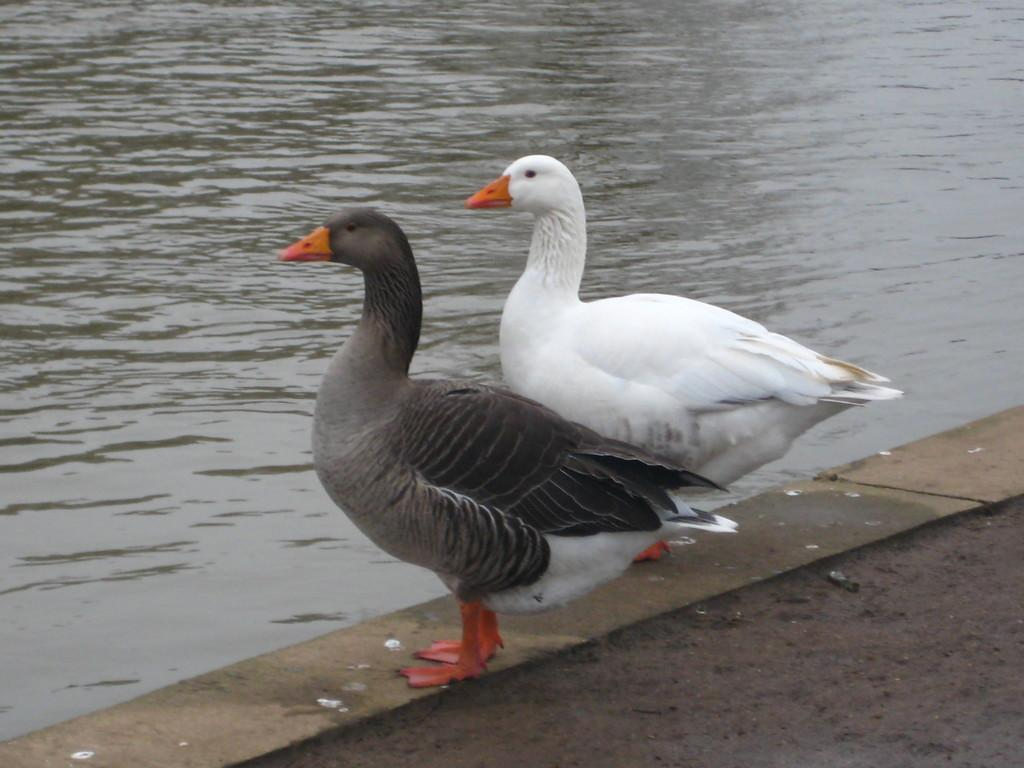What body of water is visible in the image? There is a lake in the image. Are there any animals present in the image? Yes, there are two birds in the image. Where are the birds located in relation to the lake? The birds are standing on the surface of the land. What type of tooth can be seen in the image? There is no tooth present in the image. Is there a field visible in the image? The provided facts do not mention a field, so it cannot be determined if one is present. 